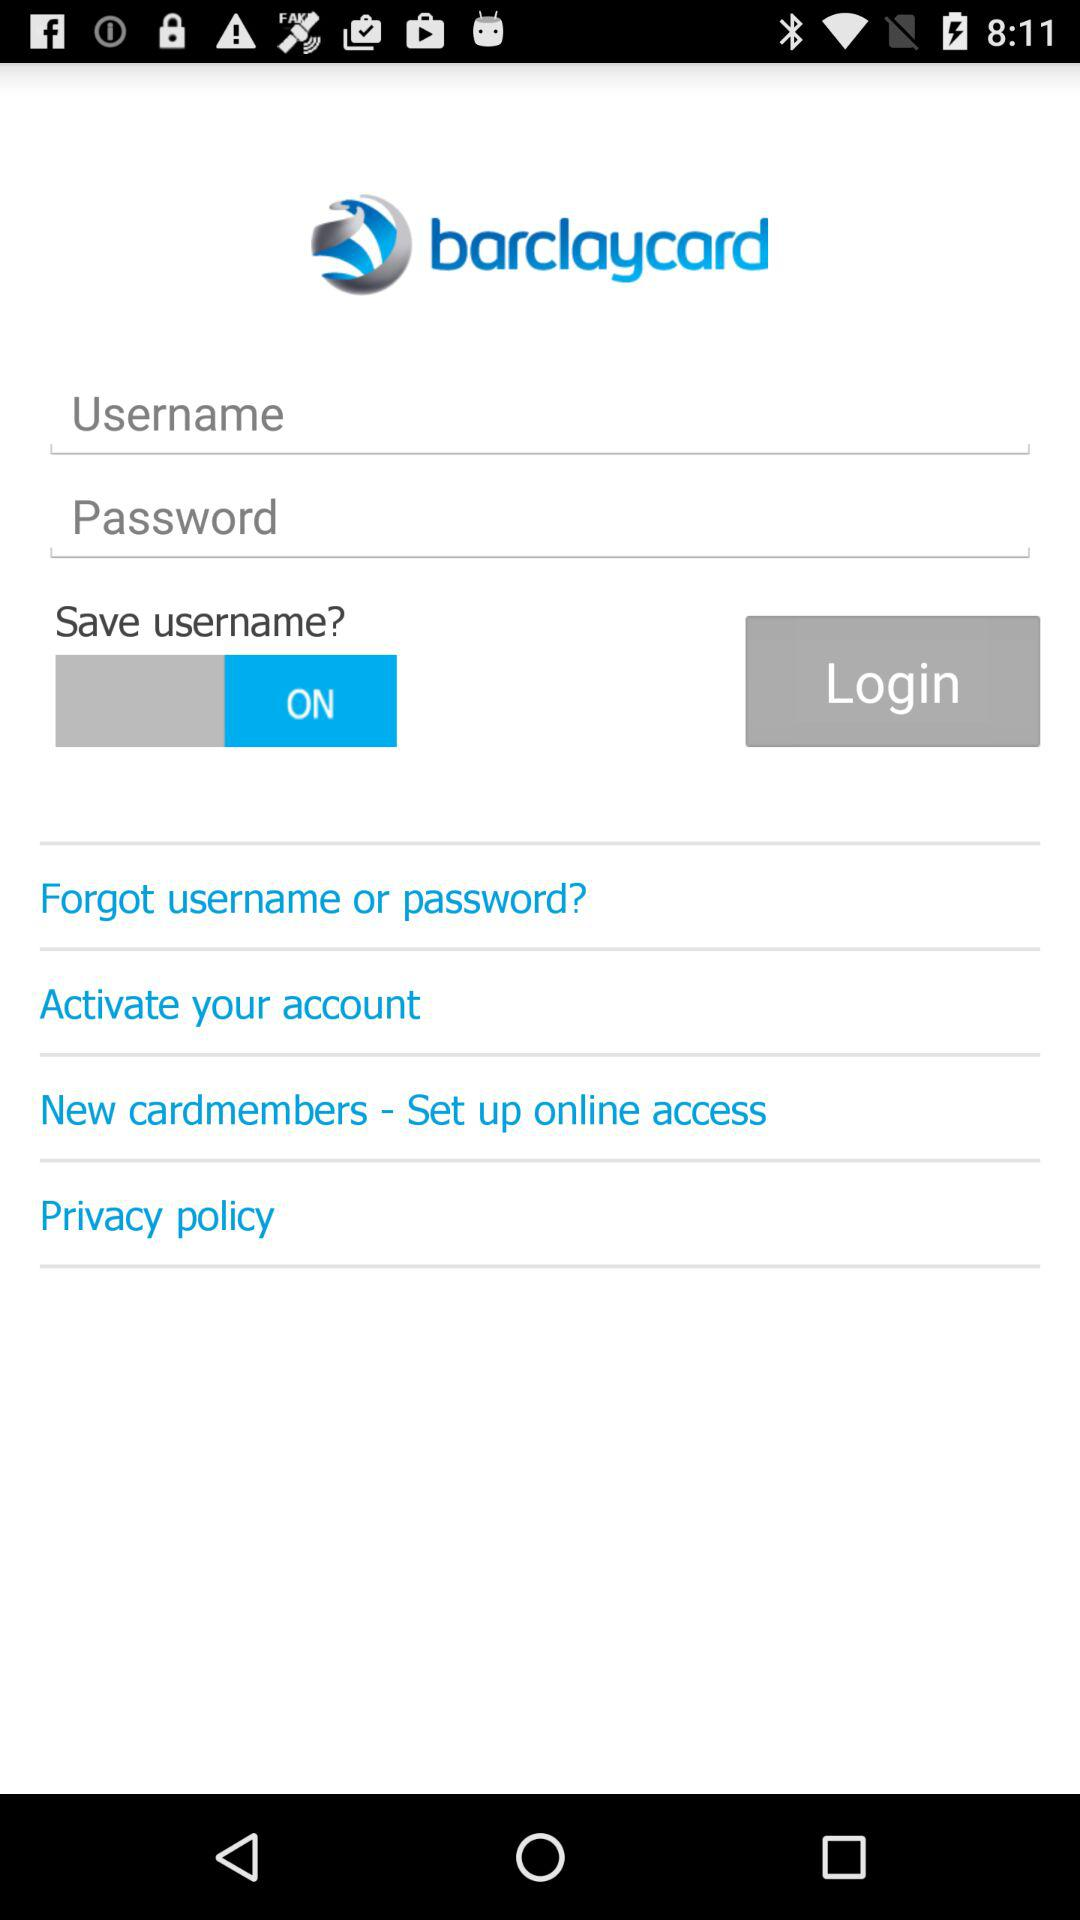What is the name of the application? The name of the application is "barclaycard". 